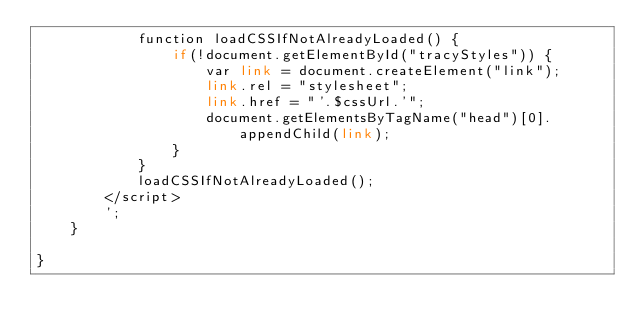Convert code to text. <code><loc_0><loc_0><loc_500><loc_500><_PHP_>			function loadCSSIfNotAlreadyLoaded() {
				if(!document.getElementById("tracyStyles")) {
				    var link = document.createElement("link");
				    link.rel = "stylesheet";
				    link.href = "'.$cssUrl.'";
				    document.getElementsByTagName("head")[0].appendChild(link);
				}
			}
			loadCSSIfNotAlreadyLoaded();
		</script>
		';
	}

}</code> 